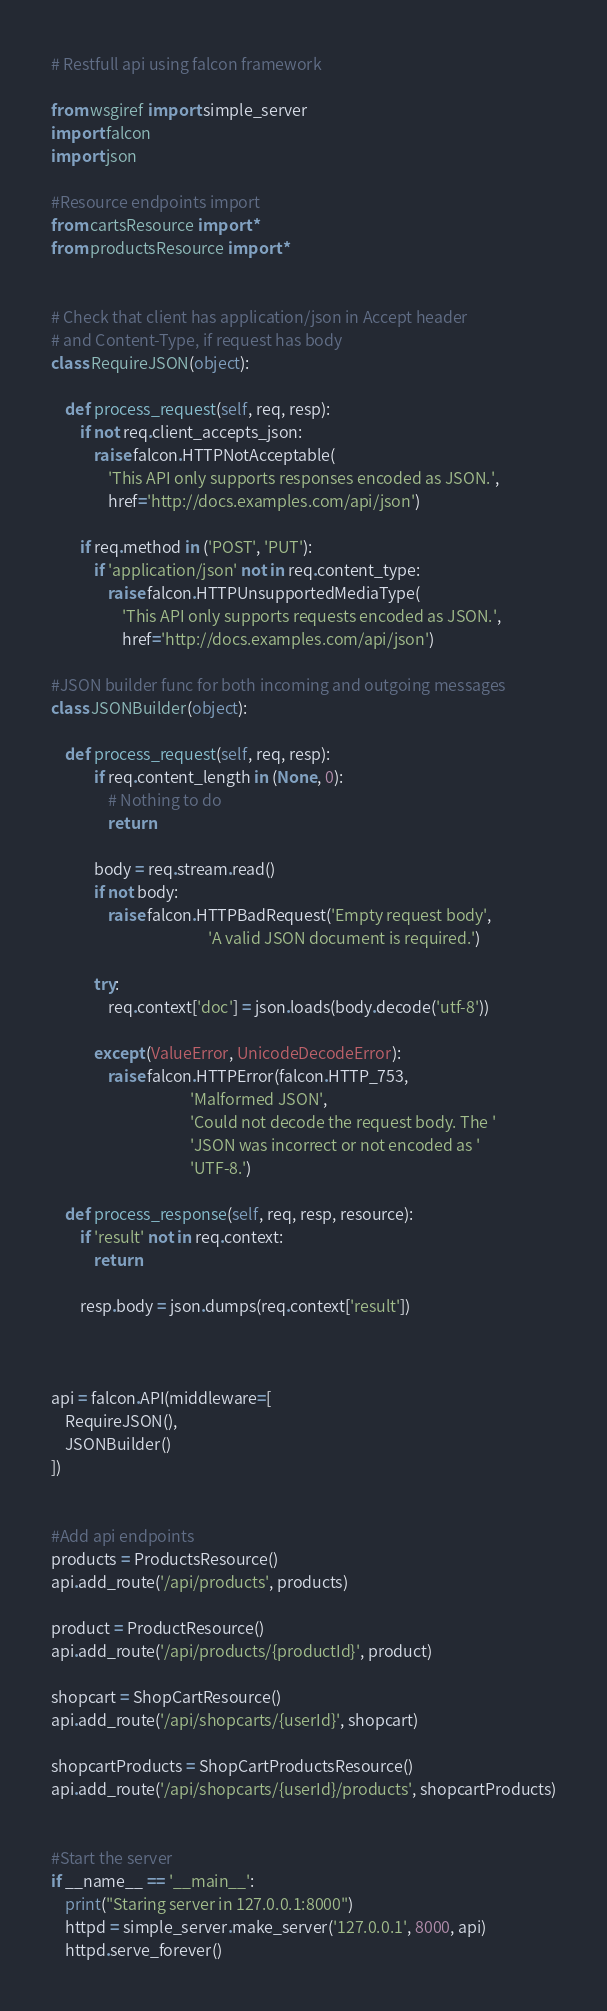<code> <loc_0><loc_0><loc_500><loc_500><_Python_>
# Restfull api using falcon framework

from wsgiref import simple_server
import falcon
import json

#Resource endpoints import
from cartsResource import *
from productsResource import *


# Check that client has application/json in Accept header
# and Content-Type, if request has body
class RequireJSON(object):

    def process_request(self, req, resp):
        if not req.client_accepts_json:
            raise falcon.HTTPNotAcceptable(
                'This API only supports responses encoded as JSON.',
                href='http://docs.examples.com/api/json')

        if req.method in ('POST', 'PUT'):
            if 'application/json' not in req.content_type:
                raise falcon.HTTPUnsupportedMediaType(
                    'This API only supports requests encoded as JSON.',
                    href='http://docs.examples.com/api/json')

#JSON builder func for both incoming and outgoing messages 
class JSONBuilder(object):

    def process_request(self, req, resp):
            if req.content_length in (None, 0):
                # Nothing to do
                return

            body = req.stream.read()
            if not body:
                raise falcon.HTTPBadRequest('Empty request body',
                                            'A valid JSON document is required.')

            try:
                req.context['doc'] = json.loads(body.decode('utf-8'))

            except (ValueError, UnicodeDecodeError):
                raise falcon.HTTPError(falcon.HTTP_753,
                                       'Malformed JSON',
                                       'Could not decode the request body. The '
                                       'JSON was incorrect or not encoded as '
                                       'UTF-8.')

    def process_response(self, req, resp, resource):
        if 'result' not in req.context:
            return

        resp.body = json.dumps(req.context['result'])



api = falcon.API(middleware=[ 
    RequireJSON(),
    JSONBuilder()
])


#Add api endpoints
products = ProductsResource()
api.add_route('/api/products', products)

product = ProductResource()
api.add_route('/api/products/{productId}', product)

shopcart = ShopCartResource()
api.add_route('/api/shopcarts/{userId}', shopcart)

shopcartProducts = ShopCartProductsResource()
api.add_route('/api/shopcarts/{userId}/products', shopcartProducts)


#Start the server 
if __name__ == '__main__':
    print("Staring server in 127.0.0.1:8000")
    httpd = simple_server.make_server('127.0.0.1', 8000, api)
    httpd.serve_forever()

</code> 